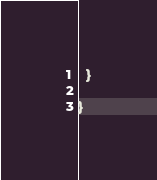<code> <loc_0><loc_0><loc_500><loc_500><_Scala_>  }

}
</code> 